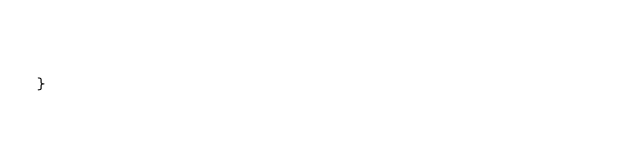Convert code to text. <code><loc_0><loc_0><loc_500><loc_500><_PHP_>       

}
</code> 